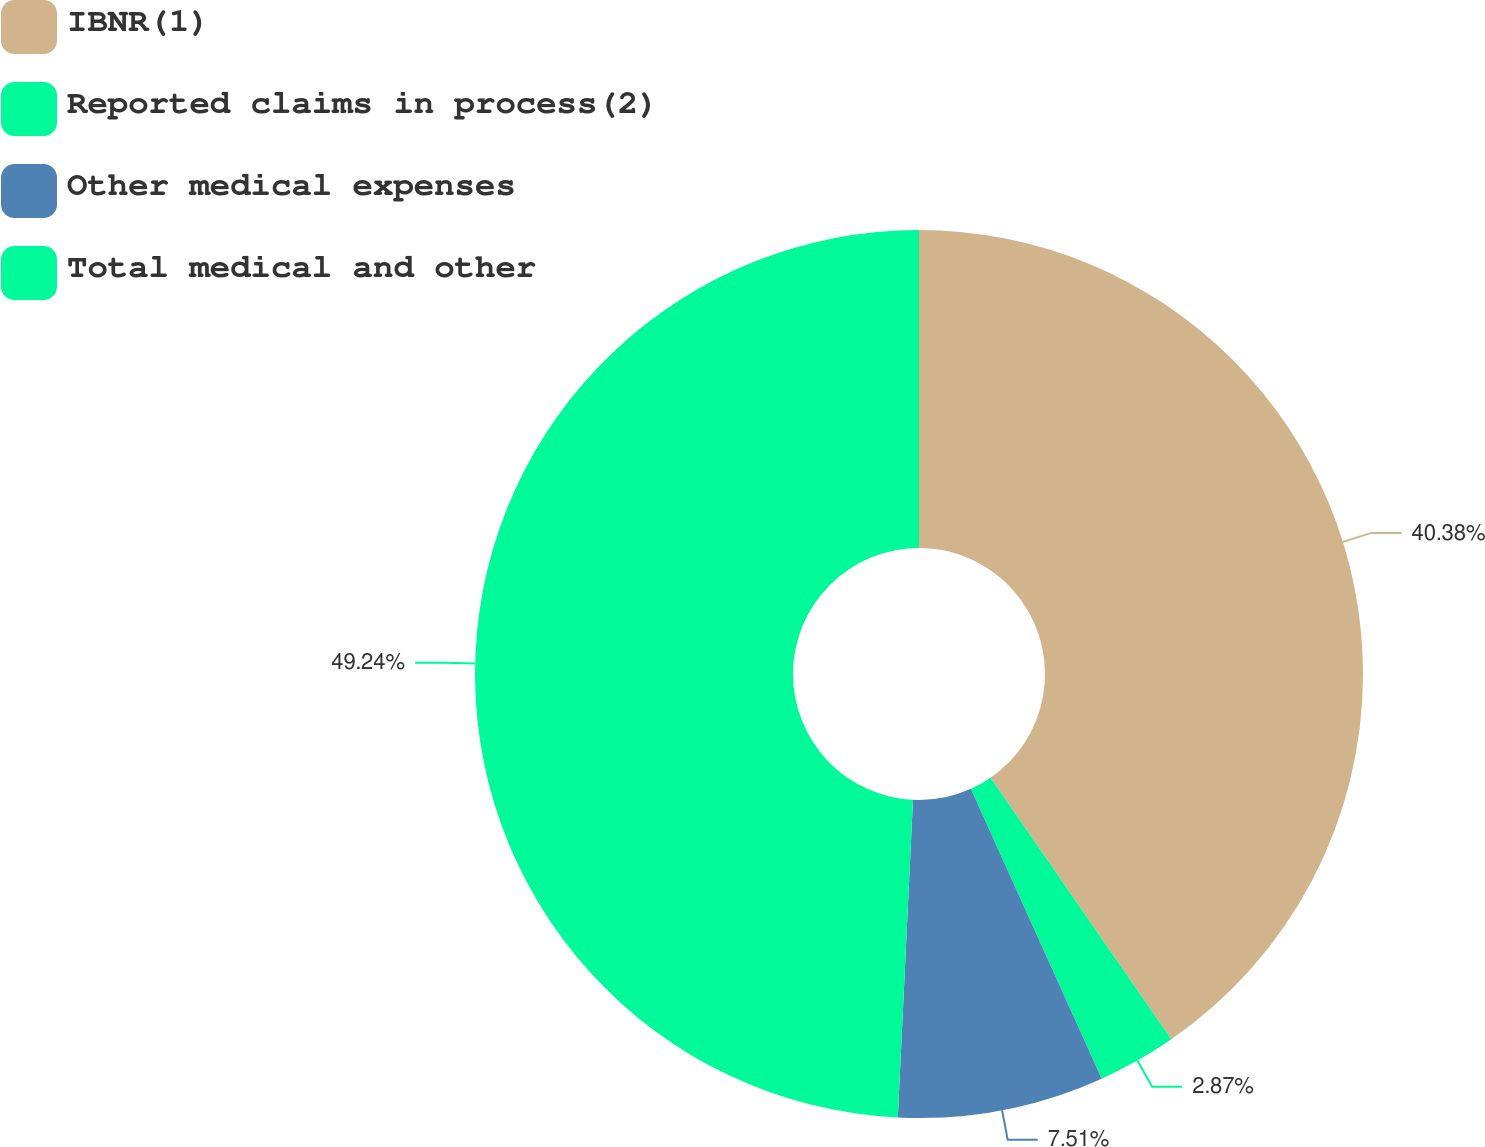Convert chart. <chart><loc_0><loc_0><loc_500><loc_500><pie_chart><fcel>IBNR(1)<fcel>Reported claims in process(2)<fcel>Other medical expenses<fcel>Total medical and other<nl><fcel>40.38%<fcel>2.87%<fcel>7.51%<fcel>49.24%<nl></chart> 